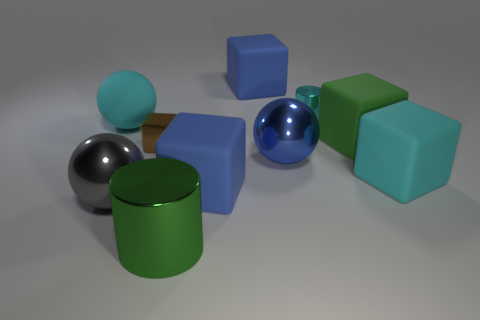Subtract 1 cubes. How many cubes are left? 4 Subtract all green cubes. How many cubes are left? 4 Subtract all tiny metal cubes. How many cubes are left? 4 Subtract all yellow blocks. Subtract all brown cylinders. How many blocks are left? 5 Subtract all cylinders. How many objects are left? 8 Subtract all green things. Subtract all big cubes. How many objects are left? 4 Add 3 brown blocks. How many brown blocks are left? 4 Add 6 cyan metal cylinders. How many cyan metal cylinders exist? 7 Subtract 0 gray blocks. How many objects are left? 10 